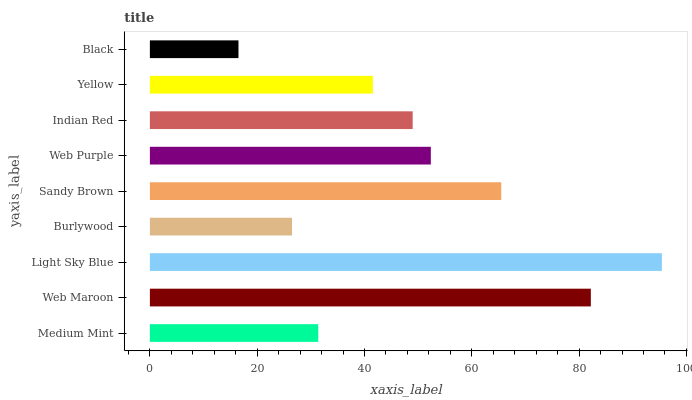Is Black the minimum?
Answer yes or no. Yes. Is Light Sky Blue the maximum?
Answer yes or no. Yes. Is Web Maroon the minimum?
Answer yes or no. No. Is Web Maroon the maximum?
Answer yes or no. No. Is Web Maroon greater than Medium Mint?
Answer yes or no. Yes. Is Medium Mint less than Web Maroon?
Answer yes or no. Yes. Is Medium Mint greater than Web Maroon?
Answer yes or no. No. Is Web Maroon less than Medium Mint?
Answer yes or no. No. Is Indian Red the high median?
Answer yes or no. Yes. Is Indian Red the low median?
Answer yes or no. Yes. Is Web Purple the high median?
Answer yes or no. No. Is Medium Mint the low median?
Answer yes or no. No. 